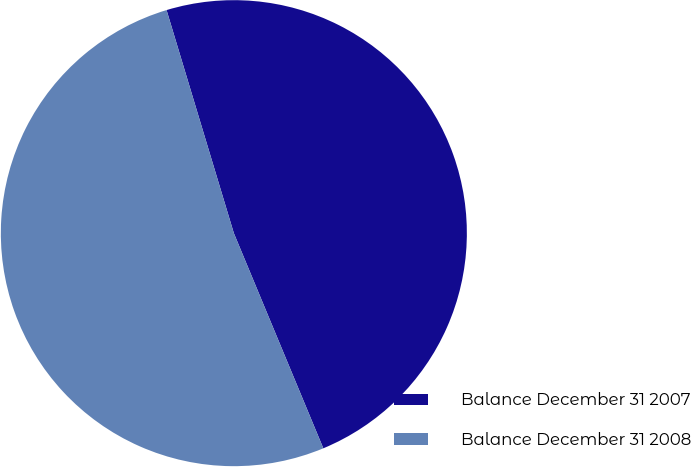Convert chart to OTSL. <chart><loc_0><loc_0><loc_500><loc_500><pie_chart><fcel>Balance December 31 2007<fcel>Balance December 31 2008<nl><fcel>48.39%<fcel>51.61%<nl></chart> 